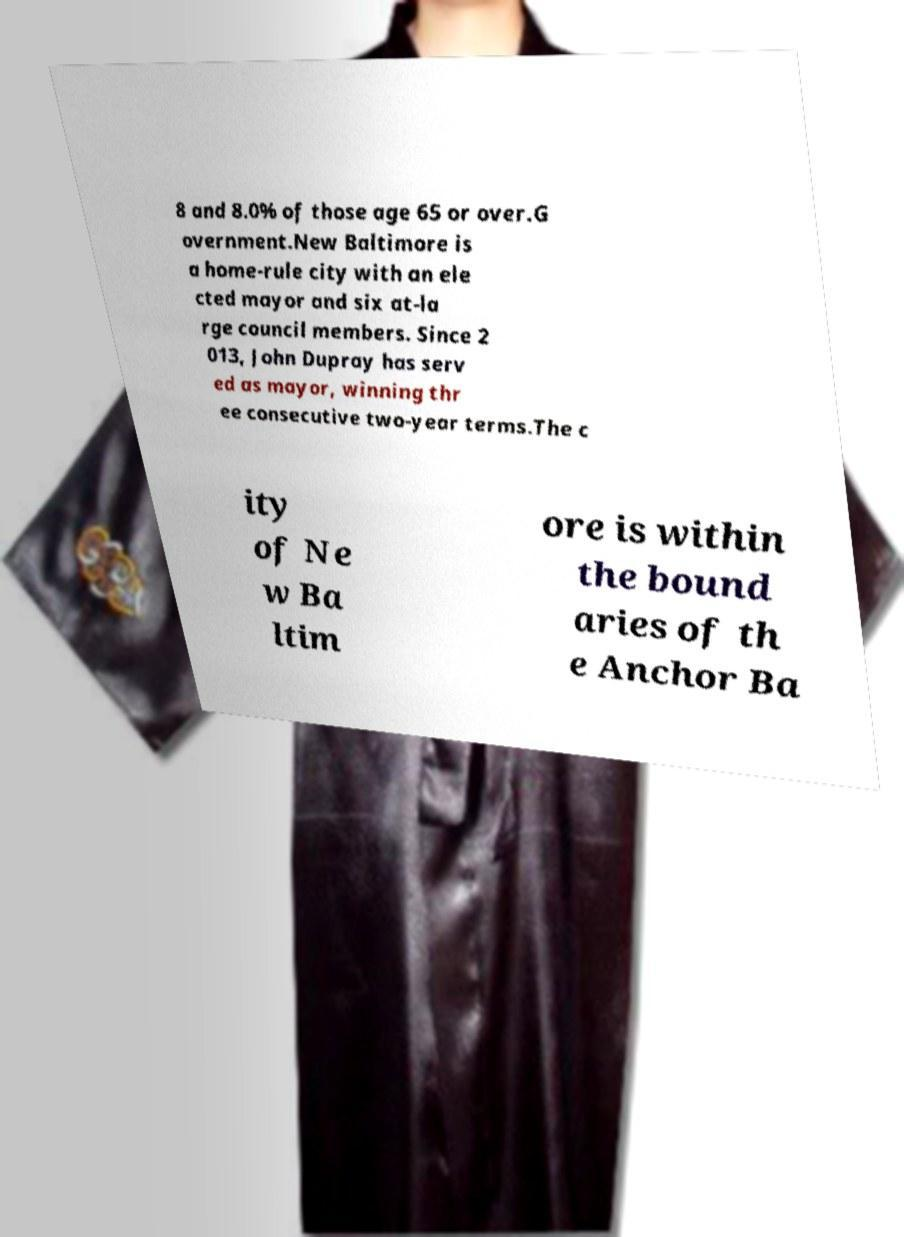Can you read and provide the text displayed in the image?This photo seems to have some interesting text. Can you extract and type it out for me? 8 and 8.0% of those age 65 or over.G overnment.New Baltimore is a home-rule city with an ele cted mayor and six at-la rge council members. Since 2 013, John Dupray has serv ed as mayor, winning thr ee consecutive two-year terms.The c ity of Ne w Ba ltim ore is within the bound aries of th e Anchor Ba 